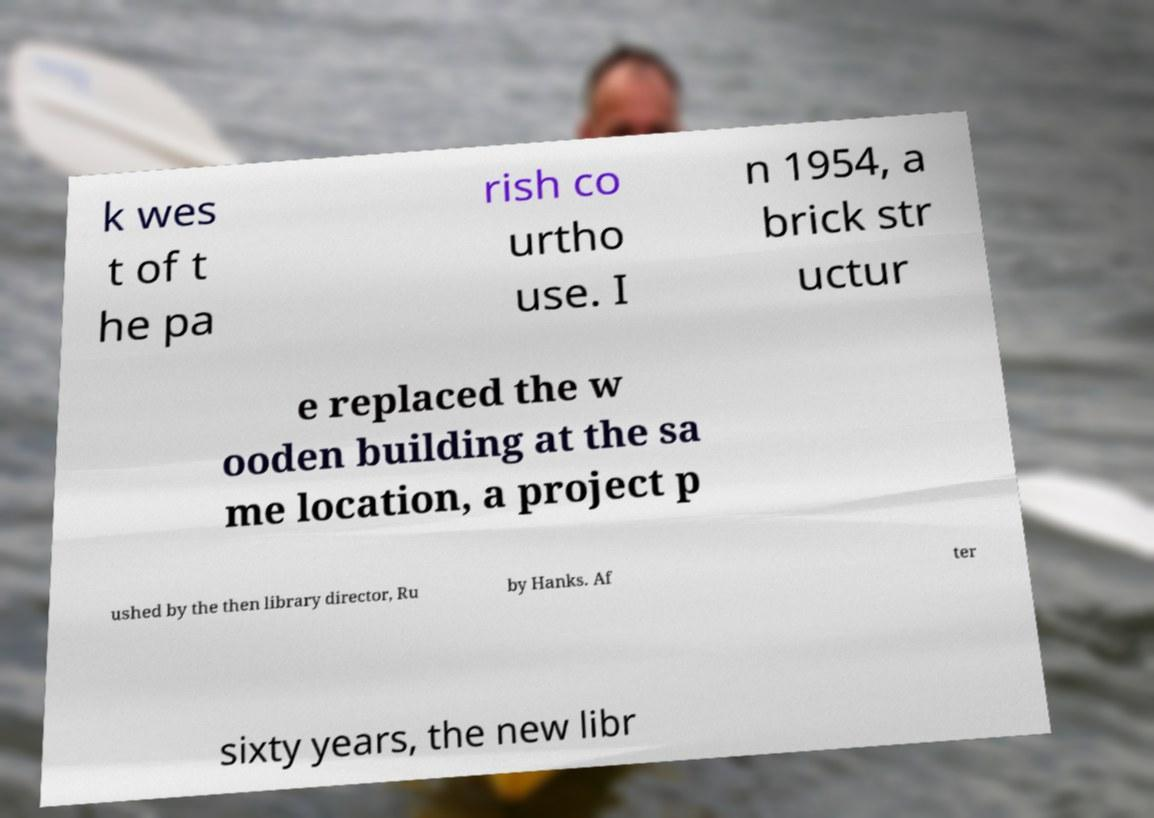What messages or text are displayed in this image? I need them in a readable, typed format. k wes t of t he pa rish co urtho use. I n 1954, a brick str uctur e replaced the w ooden building at the sa me location, a project p ushed by the then library director, Ru by Hanks. Af ter sixty years, the new libr 